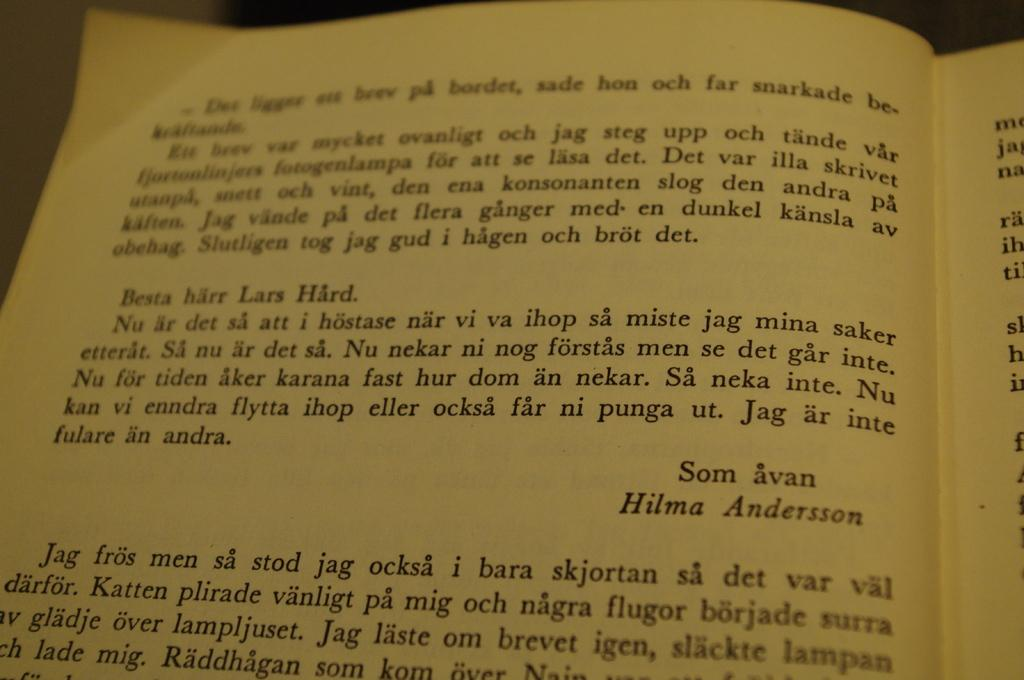<image>
Summarize the visual content of the image. The book is turned to a page in another language with the name Hilma Andersson on the page. 